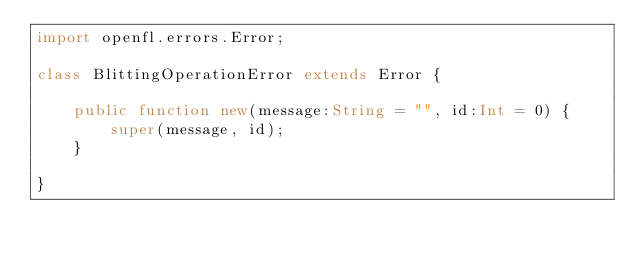Convert code to text. <code><loc_0><loc_0><loc_500><loc_500><_Haxe_>import openfl.errors.Error;

class BlittingOperationError extends Error {

    public function new(message:String = "", id:Int = 0) {
        super(message, id);
    }

}
</code> 